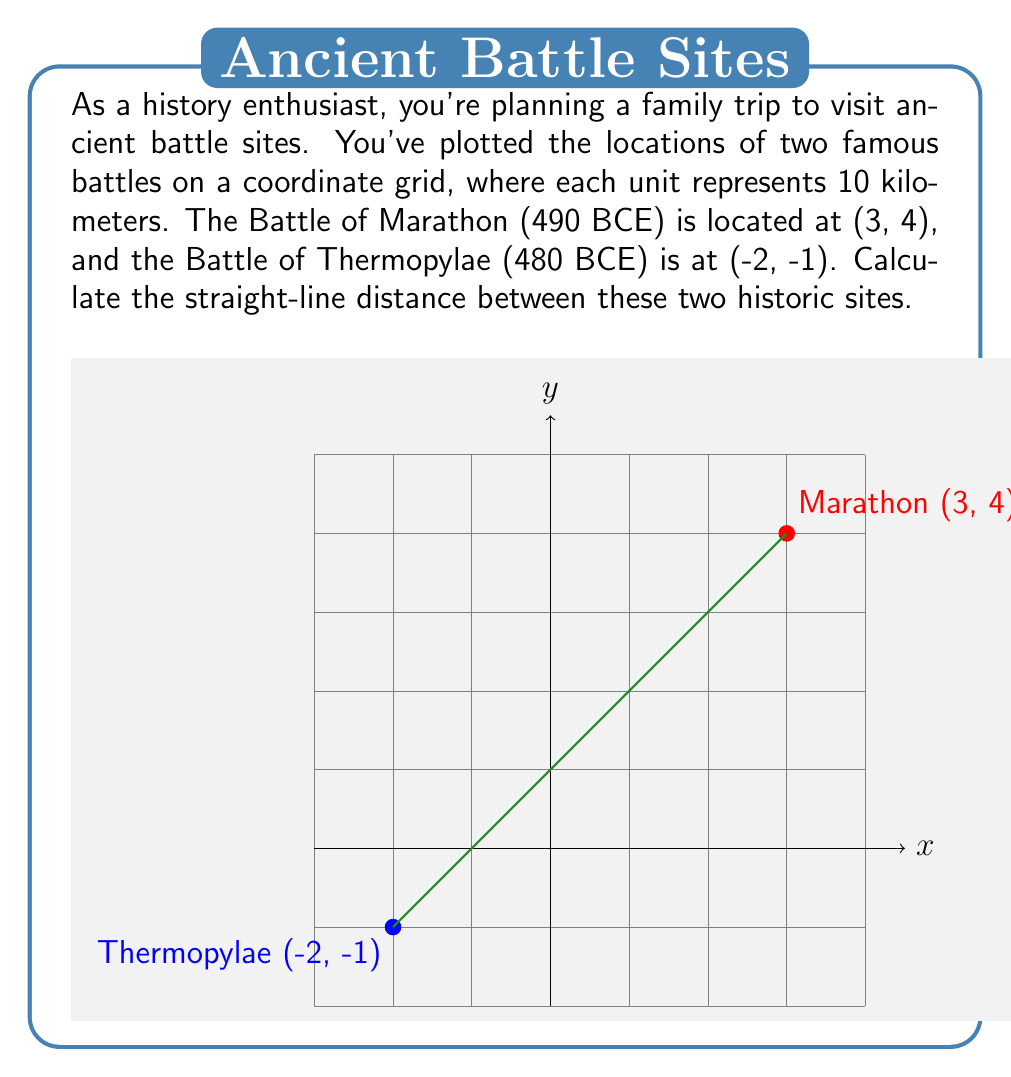Give your solution to this math problem. To find the distance between two points on a coordinate plane, we use the distance formula, which is derived from the Pythagorean theorem:

$$d = \sqrt{(x_2 - x_1)^2 + (y_2 - y_1)^2}$$

Where $(x_1, y_1)$ is the coordinate of the first point and $(x_2, y_2)$ is the coordinate of the second point.

Let's plug in our values:
$(x_1, y_1) = (-2, -1)$ for Thermopylae
$(x_2, y_2) = (3, 4)$ for Marathon

$$d = \sqrt{(3 - (-2))^2 + (4 - (-1))^2}$$

Simplify inside the parentheses:
$$d = \sqrt{(3 + 2)^2 + (4 + 1)^2}$$
$$d = \sqrt{5^2 + 5^2}$$

Calculate the squares:
$$d = \sqrt{25 + 25}$$
$$d = \sqrt{50}$$

Simplify the square root:
$$d = 5\sqrt{2}$$

Remember that each unit represents 10 kilometers, so we need to multiply our result by 10:

$$d = 10 \cdot 5\sqrt{2} = 50\sqrt{2} \text{ km}$$

This can be approximated to about 70.71 km.
Answer: $50\sqrt{2}$ km 